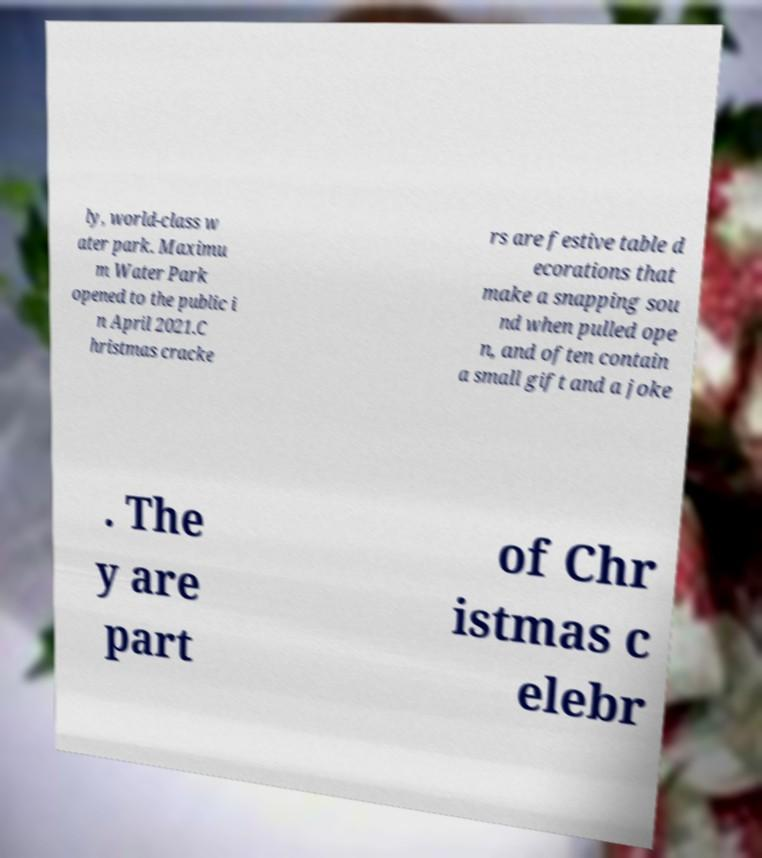Please identify and transcribe the text found in this image. ly, world-class w ater park. Maximu m Water Park opened to the public i n April 2021.C hristmas cracke rs are festive table d ecorations that make a snapping sou nd when pulled ope n, and often contain a small gift and a joke . The y are part of Chr istmas c elebr 